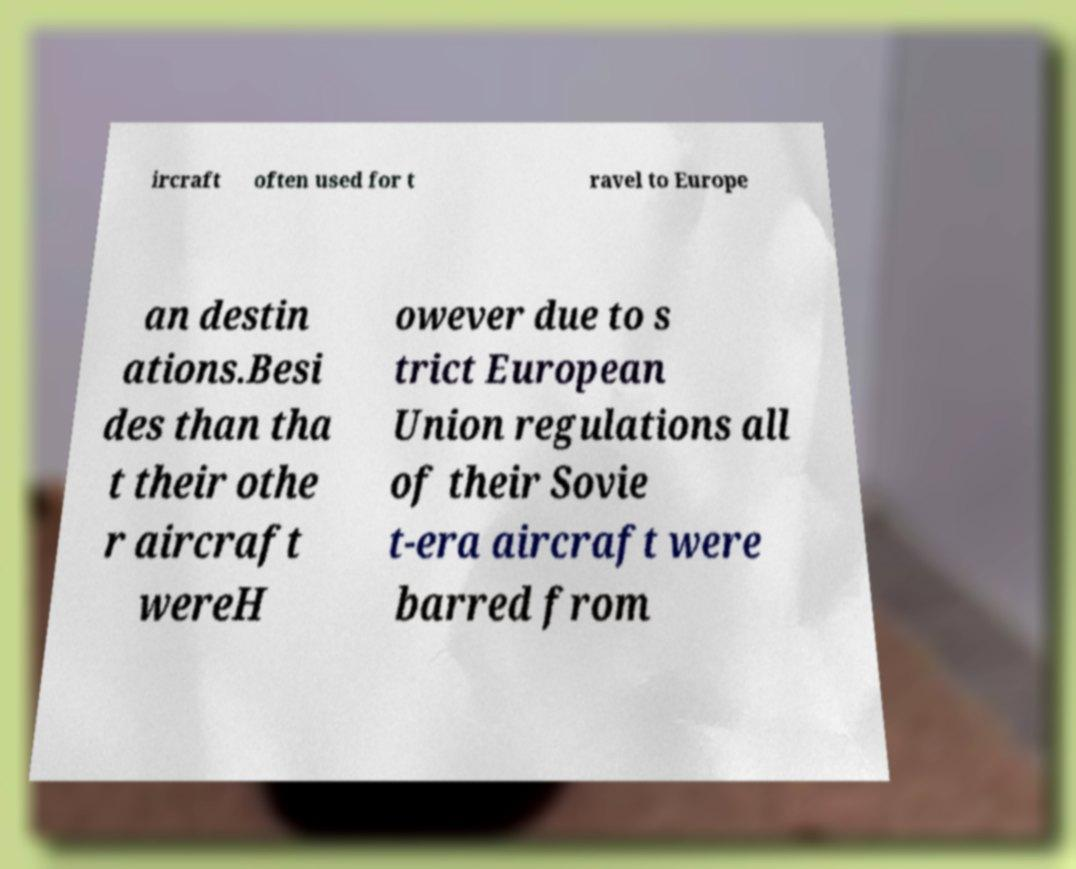Can you accurately transcribe the text from the provided image for me? ircraft often used for t ravel to Europe an destin ations.Besi des than tha t their othe r aircraft wereH owever due to s trict European Union regulations all of their Sovie t-era aircraft were barred from 